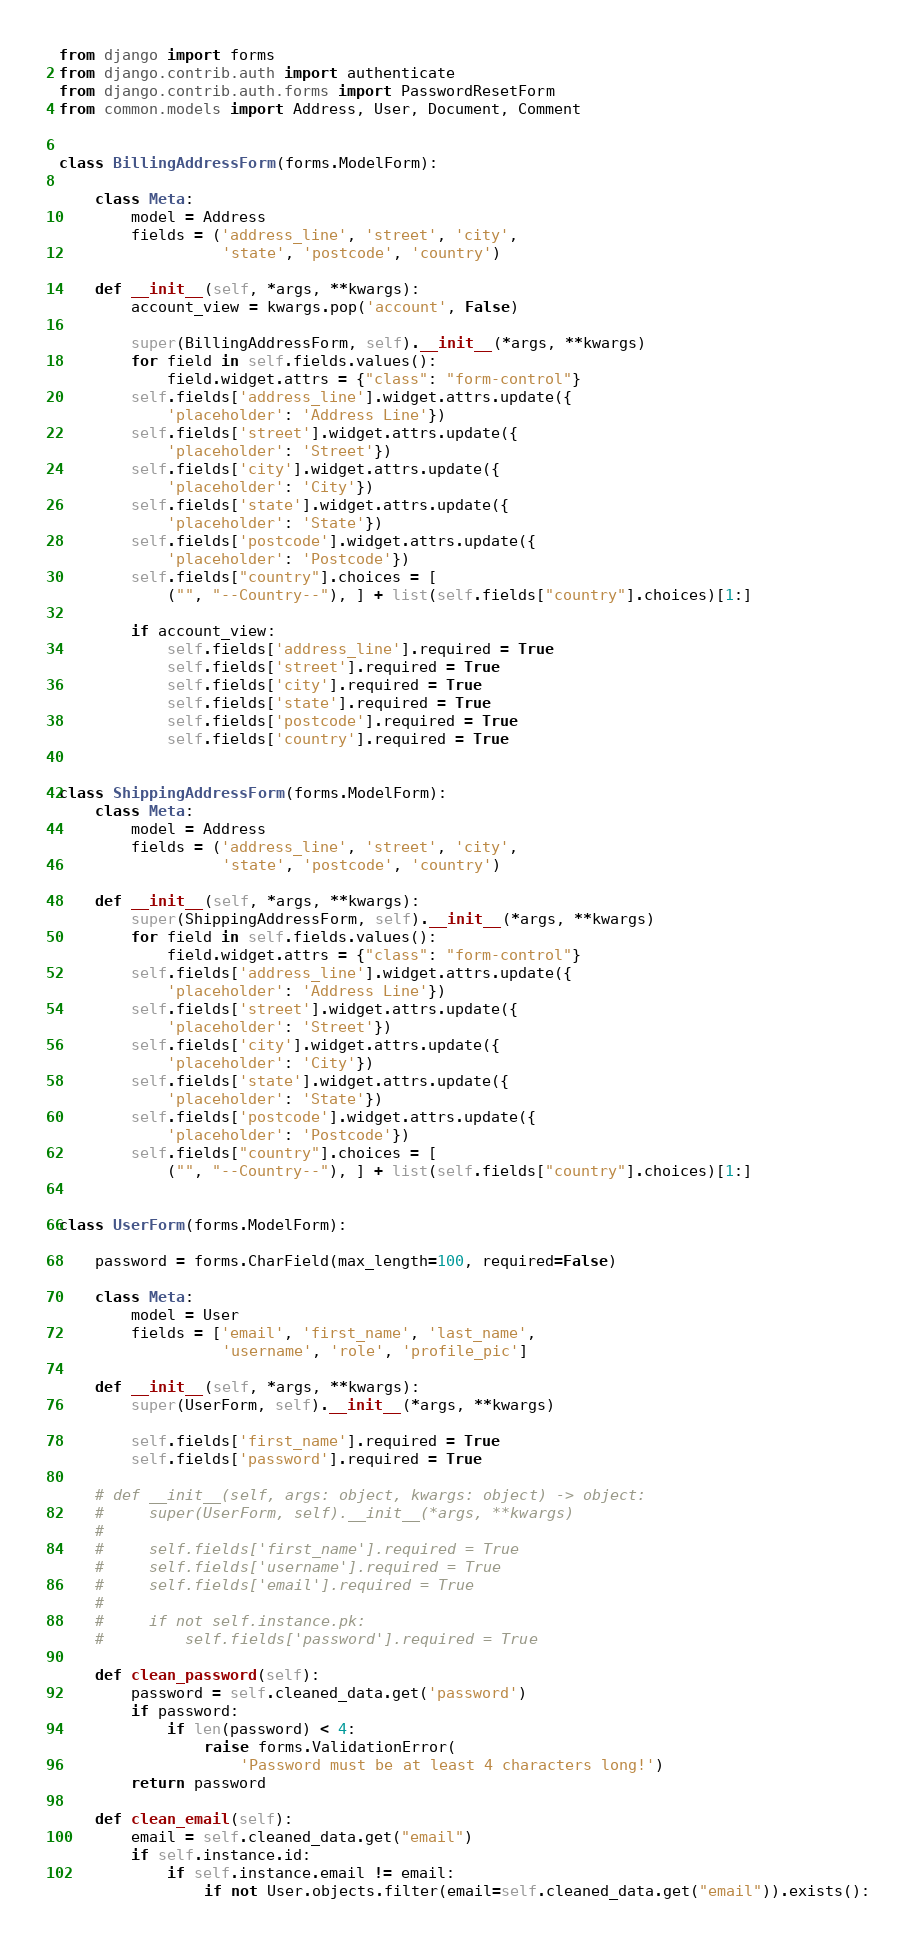Convert code to text. <code><loc_0><loc_0><loc_500><loc_500><_Python_>from django import forms
from django.contrib.auth import authenticate
from django.contrib.auth.forms import PasswordResetForm
from common.models import Address, User, Document, Comment


class BillingAddressForm(forms.ModelForm):

    class Meta:
        model = Address
        fields = ('address_line', 'street', 'city',
                  'state', 'postcode', 'country')

    def __init__(self, *args, **kwargs):
        account_view = kwargs.pop('account', False)

        super(BillingAddressForm, self).__init__(*args, **kwargs)
        for field in self.fields.values():
            field.widget.attrs = {"class": "form-control"}
        self.fields['address_line'].widget.attrs.update({
            'placeholder': 'Address Line'})
        self.fields['street'].widget.attrs.update({
            'placeholder': 'Street'})
        self.fields['city'].widget.attrs.update({
            'placeholder': 'City'})
        self.fields['state'].widget.attrs.update({
            'placeholder': 'State'})
        self.fields['postcode'].widget.attrs.update({
            'placeholder': 'Postcode'})
        self.fields["country"].choices = [
            ("", "--Country--"), ] + list(self.fields["country"].choices)[1:]

        if account_view:
            self.fields['address_line'].required = True
            self.fields['street'].required = True
            self.fields['city'].required = True
            self.fields['state'].required = True
            self.fields['postcode'].required = True
            self.fields['country'].required = True


class ShippingAddressForm(forms.ModelForm):
    class Meta:
        model = Address
        fields = ('address_line', 'street', 'city',
                  'state', 'postcode', 'country')

    def __init__(self, *args, **kwargs):
        super(ShippingAddressForm, self).__init__(*args, **kwargs)
        for field in self.fields.values():
            field.widget.attrs = {"class": "form-control"}
        self.fields['address_line'].widget.attrs.update({
            'placeholder': 'Address Line'})
        self.fields['street'].widget.attrs.update({
            'placeholder': 'Street'})
        self.fields['city'].widget.attrs.update({
            'placeholder': 'City'})
        self.fields['state'].widget.attrs.update({
            'placeholder': 'State'})
        self.fields['postcode'].widget.attrs.update({
            'placeholder': 'Postcode'})
        self.fields["country"].choices = [
            ("", "--Country--"), ] + list(self.fields["country"].choices)[1:]


class UserForm(forms.ModelForm):

    password = forms.CharField(max_length=100, required=False)

    class Meta:
        model = User
        fields = ['email', 'first_name', 'last_name',
                  'username', 'role', 'profile_pic']

    def __init__(self, *args, **kwargs):
        super(UserForm, self).__init__(*args, **kwargs)

        self.fields['first_name'].required = True
        self.fields['password'].required = True

    # def __init__(self, args: object, kwargs: object) -> object:
    #     super(UserForm, self).__init__(*args, **kwargs)
    #
    #     self.fields['first_name'].required = True
    #     self.fields['username'].required = True
    #     self.fields['email'].required = True
    #
    #     if not self.instance.pk:
    #         self.fields['password'].required = True

    def clean_password(self):
        password = self.cleaned_data.get('password')
        if password:
            if len(password) < 4:
                raise forms.ValidationError(
                    'Password must be at least 4 characters long!')
        return password

    def clean_email(self):
        email = self.cleaned_data.get("email")
        if self.instance.id:
            if self.instance.email != email:
                if not User.objects.filter(email=self.cleaned_data.get("email")).exists():</code> 